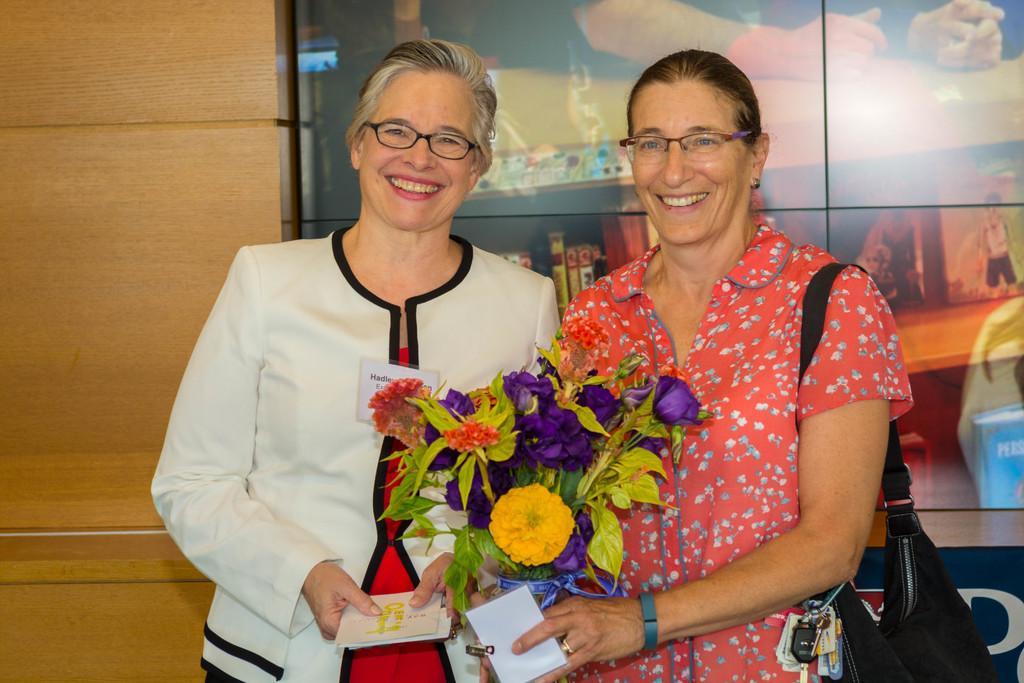Could you give a brief overview of what you see in this image? In this picture there is a woman who is wearing spectacle and white dress. Beside her we can see another woman who is in red dress. Both of them holding a book and she is holding a bouquet. In the back we can see banner. On the left there is a wooden wall. 